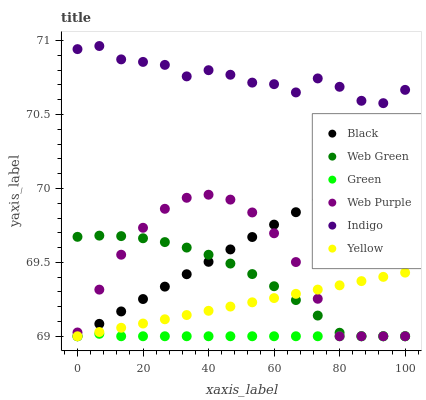Does Green have the minimum area under the curve?
Answer yes or no. Yes. Does Indigo have the maximum area under the curve?
Answer yes or no. Yes. Does Yellow have the minimum area under the curve?
Answer yes or no. No. Does Yellow have the maximum area under the curve?
Answer yes or no. No. Is Black the smoothest?
Answer yes or no. Yes. Is Indigo the roughest?
Answer yes or no. Yes. Is Yellow the smoothest?
Answer yes or no. No. Is Yellow the roughest?
Answer yes or no. No. Does Yellow have the lowest value?
Answer yes or no. Yes. Does Indigo have the highest value?
Answer yes or no. Yes. Does Yellow have the highest value?
Answer yes or no. No. Is Yellow less than Indigo?
Answer yes or no. Yes. Is Indigo greater than Black?
Answer yes or no. Yes. Does Black intersect Green?
Answer yes or no. Yes. Is Black less than Green?
Answer yes or no. No. Is Black greater than Green?
Answer yes or no. No. Does Yellow intersect Indigo?
Answer yes or no. No. 